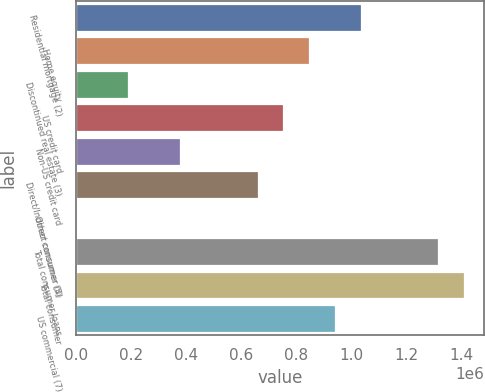Convert chart. <chart><loc_0><loc_0><loc_500><loc_500><bar_chart><fcel>Residential mortgage (2)<fcel>Home equity<fcel>Discontinued real estate (3)<fcel>US credit card<fcel>Non-US credit card<fcel>Direct/Indirect consumer (4)<fcel>Other consumer (5)<fcel>Total consumer loans<fcel>Total consumer<fcel>US commercial (7)<nl><fcel>1.0342e+06<fcel>846679<fcel>190352<fcel>752918<fcel>377874<fcel>659157<fcel>2830<fcel>1.31548e+06<fcel>1.40924e+06<fcel>940440<nl></chart> 